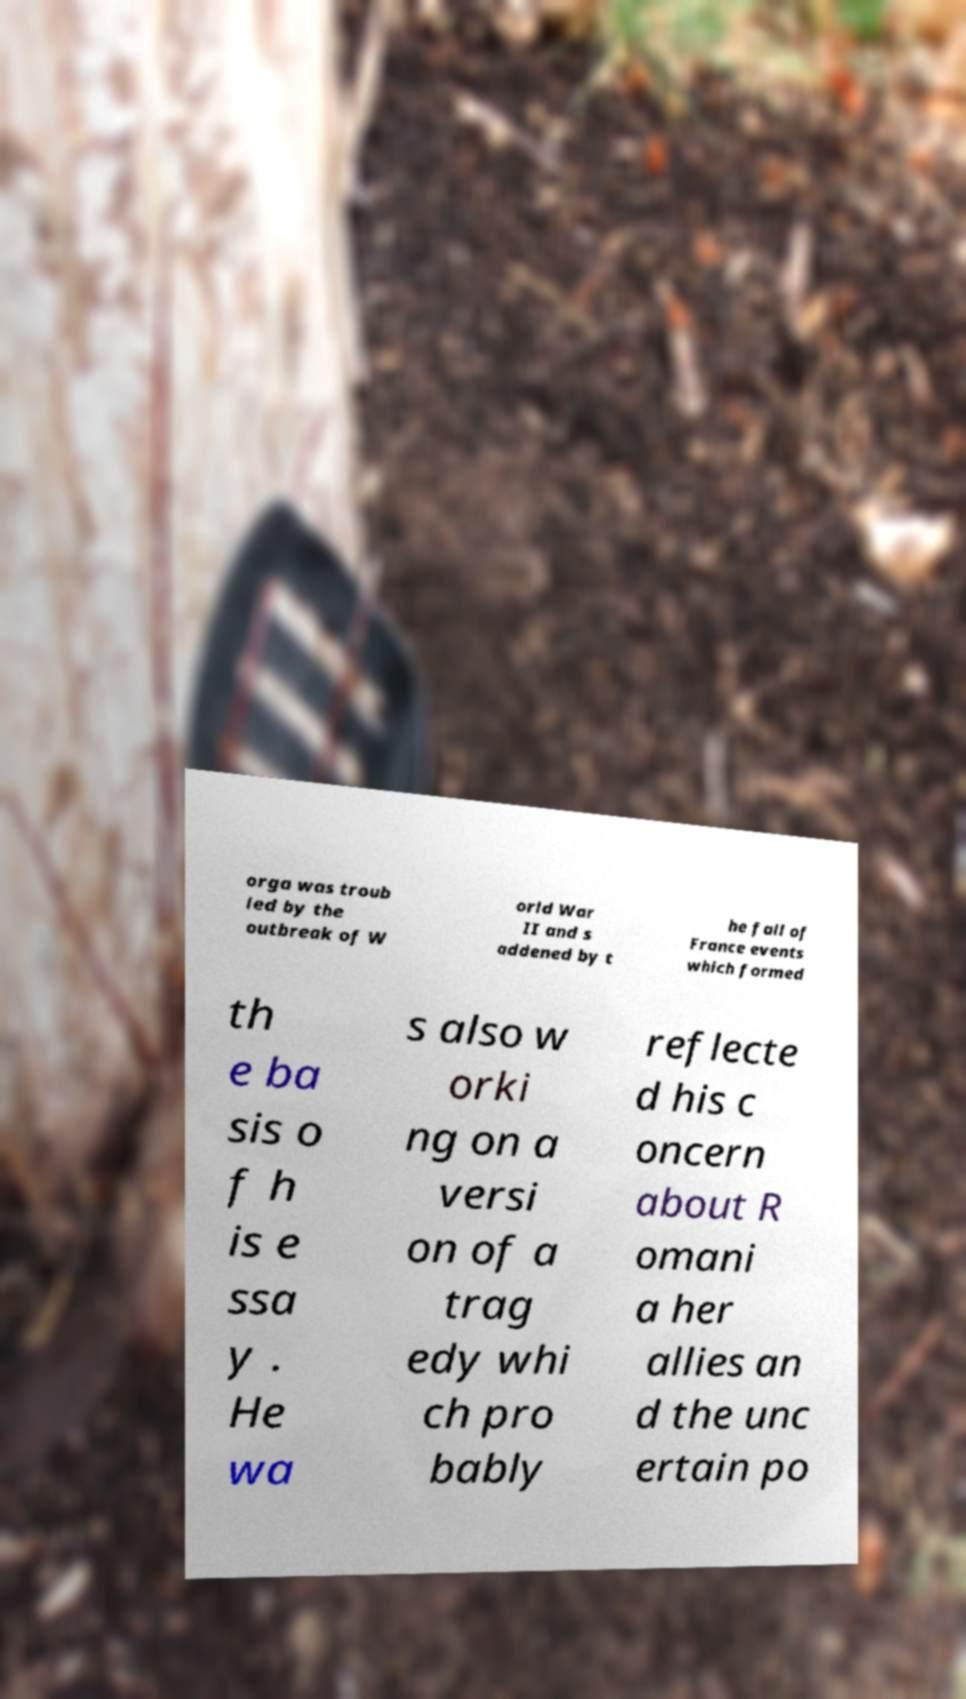Can you read and provide the text displayed in the image?This photo seems to have some interesting text. Can you extract and type it out for me? orga was troub led by the outbreak of W orld War II and s addened by t he fall of France events which formed th e ba sis o f h is e ssa y . He wa s also w orki ng on a versi on of a trag edy whi ch pro bably reflecte d his c oncern about R omani a her allies an d the unc ertain po 